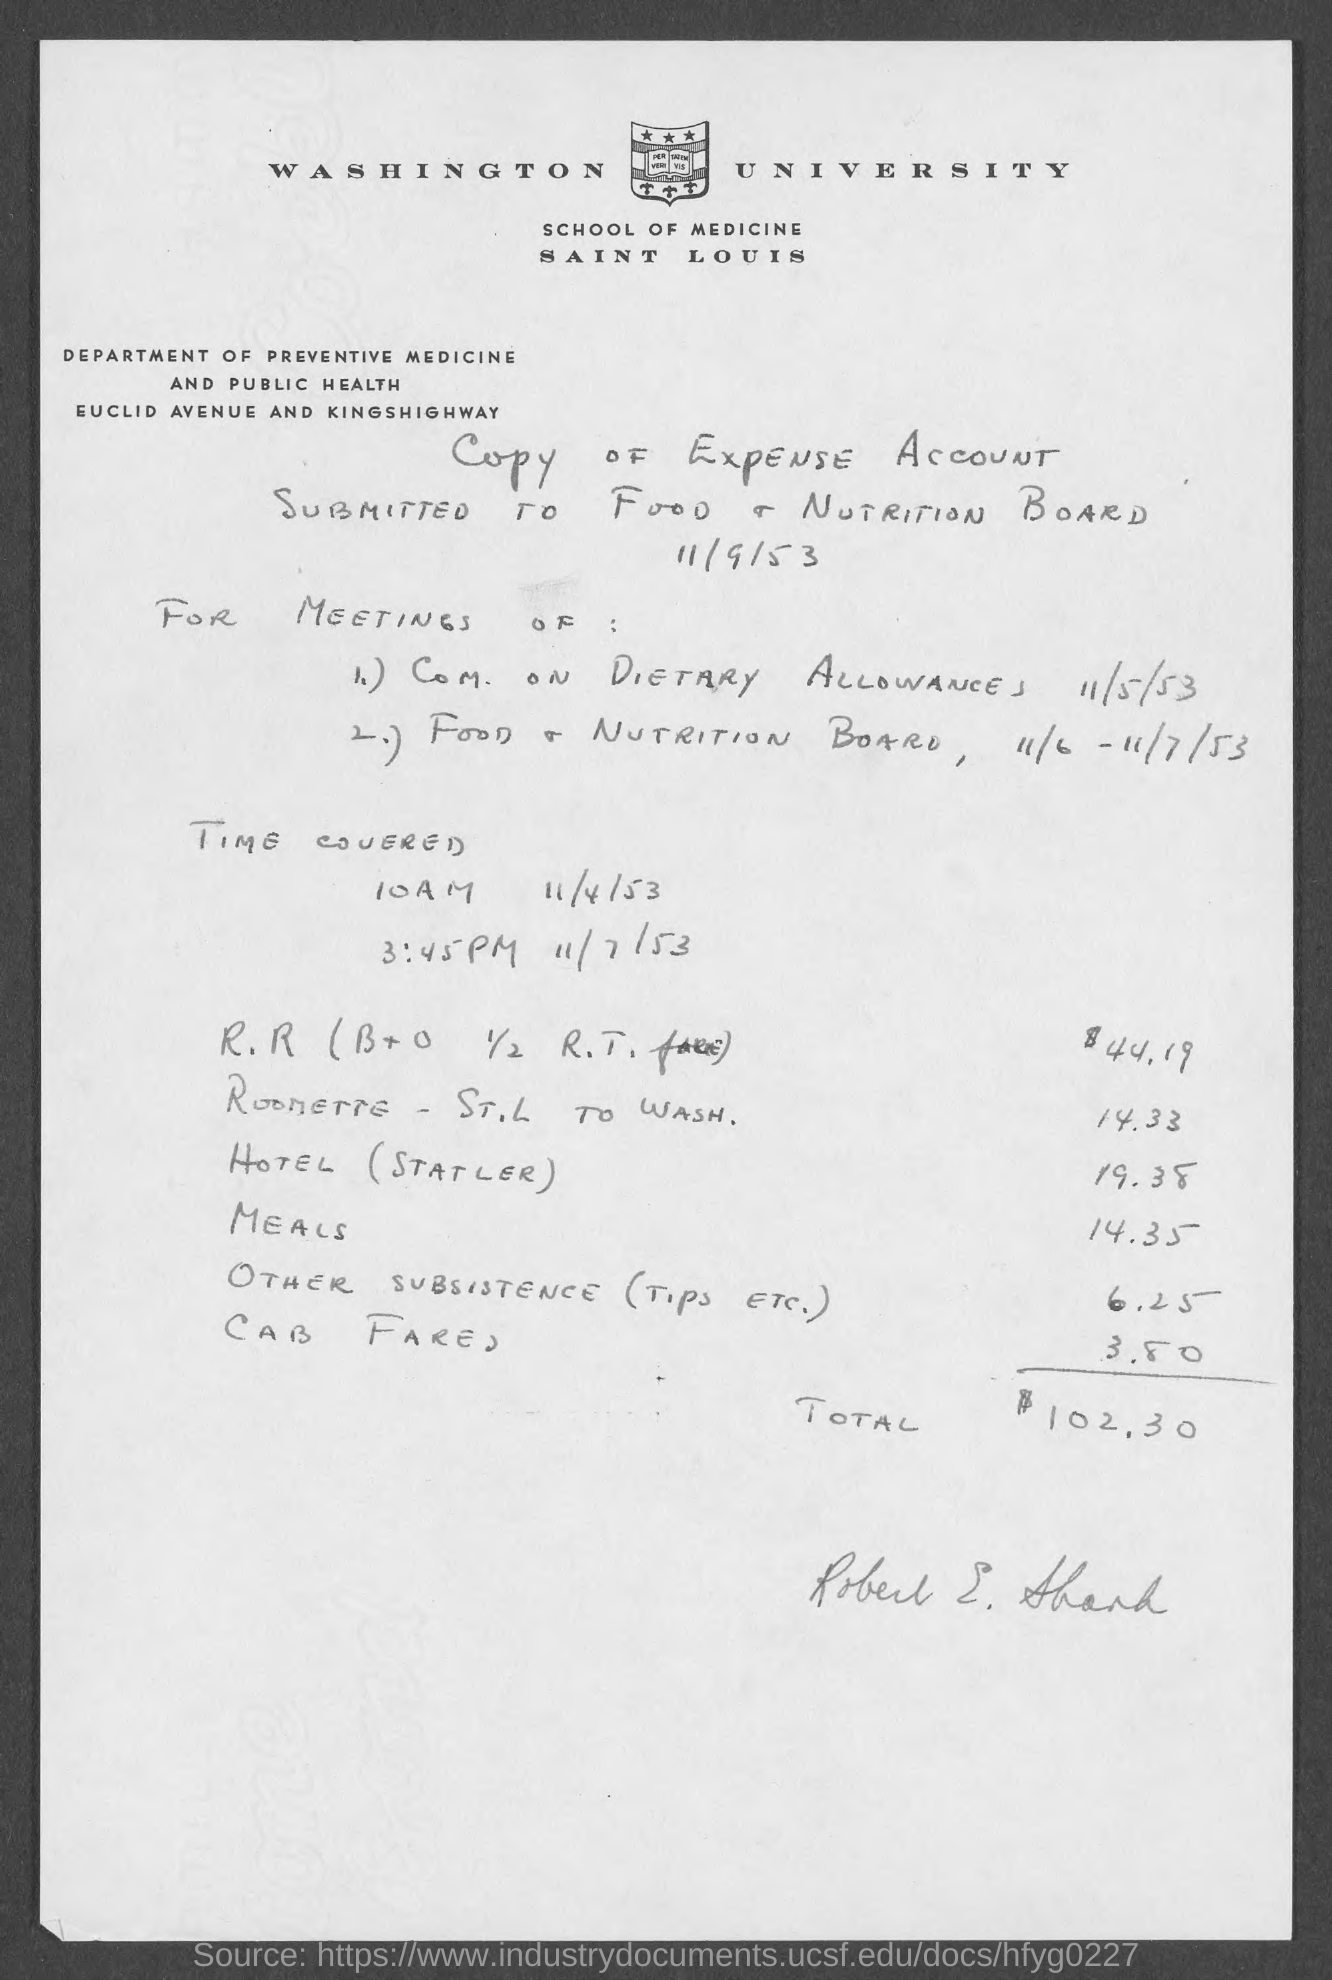Outline some significant characteristics in this image. This expense account is submitted to the Food & Nutrition Board. The city address of Washington University is located in Saint Louis, Missouri. The total amount of expenses is $102.30. 